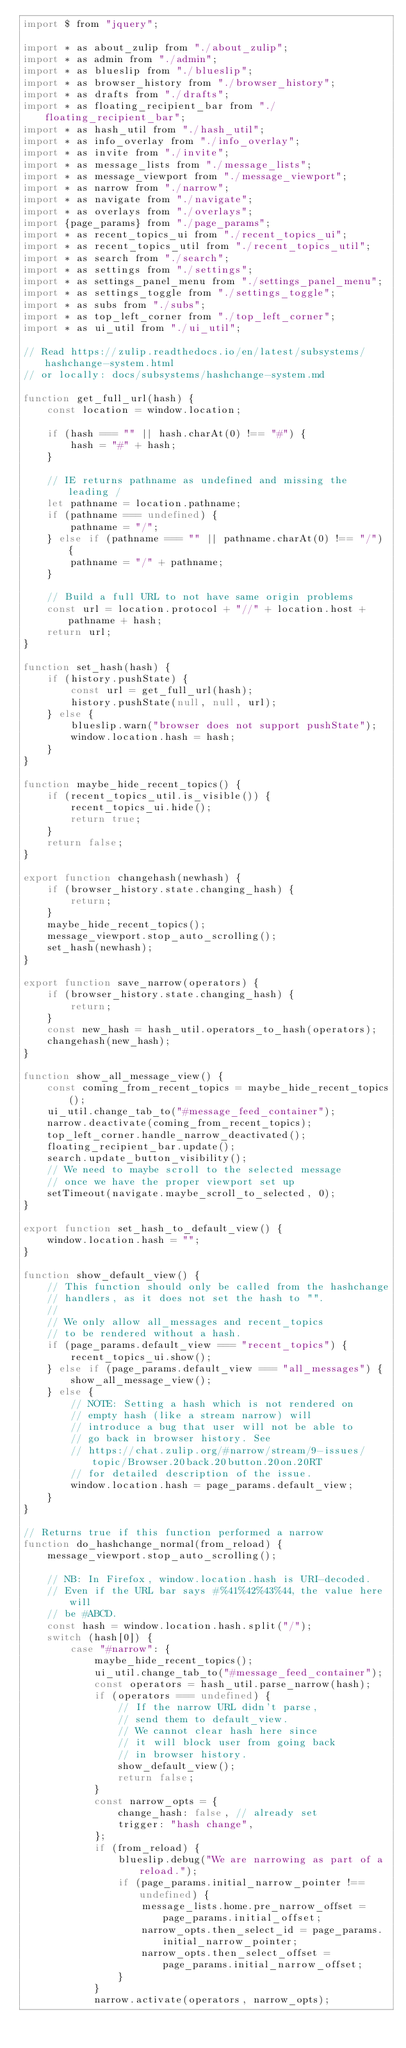Convert code to text. <code><loc_0><loc_0><loc_500><loc_500><_JavaScript_>import $ from "jquery";

import * as about_zulip from "./about_zulip";
import * as admin from "./admin";
import * as blueslip from "./blueslip";
import * as browser_history from "./browser_history";
import * as drafts from "./drafts";
import * as floating_recipient_bar from "./floating_recipient_bar";
import * as hash_util from "./hash_util";
import * as info_overlay from "./info_overlay";
import * as invite from "./invite";
import * as message_lists from "./message_lists";
import * as message_viewport from "./message_viewport";
import * as narrow from "./narrow";
import * as navigate from "./navigate";
import * as overlays from "./overlays";
import {page_params} from "./page_params";
import * as recent_topics_ui from "./recent_topics_ui";
import * as recent_topics_util from "./recent_topics_util";
import * as search from "./search";
import * as settings from "./settings";
import * as settings_panel_menu from "./settings_panel_menu";
import * as settings_toggle from "./settings_toggle";
import * as subs from "./subs";
import * as top_left_corner from "./top_left_corner";
import * as ui_util from "./ui_util";

// Read https://zulip.readthedocs.io/en/latest/subsystems/hashchange-system.html
// or locally: docs/subsystems/hashchange-system.md

function get_full_url(hash) {
    const location = window.location;

    if (hash === "" || hash.charAt(0) !== "#") {
        hash = "#" + hash;
    }

    // IE returns pathname as undefined and missing the leading /
    let pathname = location.pathname;
    if (pathname === undefined) {
        pathname = "/";
    } else if (pathname === "" || pathname.charAt(0) !== "/") {
        pathname = "/" + pathname;
    }

    // Build a full URL to not have same origin problems
    const url = location.protocol + "//" + location.host + pathname + hash;
    return url;
}

function set_hash(hash) {
    if (history.pushState) {
        const url = get_full_url(hash);
        history.pushState(null, null, url);
    } else {
        blueslip.warn("browser does not support pushState");
        window.location.hash = hash;
    }
}

function maybe_hide_recent_topics() {
    if (recent_topics_util.is_visible()) {
        recent_topics_ui.hide();
        return true;
    }
    return false;
}

export function changehash(newhash) {
    if (browser_history.state.changing_hash) {
        return;
    }
    maybe_hide_recent_topics();
    message_viewport.stop_auto_scrolling();
    set_hash(newhash);
}

export function save_narrow(operators) {
    if (browser_history.state.changing_hash) {
        return;
    }
    const new_hash = hash_util.operators_to_hash(operators);
    changehash(new_hash);
}

function show_all_message_view() {
    const coming_from_recent_topics = maybe_hide_recent_topics();
    ui_util.change_tab_to("#message_feed_container");
    narrow.deactivate(coming_from_recent_topics);
    top_left_corner.handle_narrow_deactivated();
    floating_recipient_bar.update();
    search.update_button_visibility();
    // We need to maybe scroll to the selected message
    // once we have the proper viewport set up
    setTimeout(navigate.maybe_scroll_to_selected, 0);
}

export function set_hash_to_default_view() {
    window.location.hash = "";
}

function show_default_view() {
    // This function should only be called from the hashchange
    // handlers, as it does not set the hash to "".
    //
    // We only allow all_messages and recent_topics
    // to be rendered without a hash.
    if (page_params.default_view === "recent_topics") {
        recent_topics_ui.show();
    } else if (page_params.default_view === "all_messages") {
        show_all_message_view();
    } else {
        // NOTE: Setting a hash which is not rendered on
        // empty hash (like a stream narrow) will
        // introduce a bug that user will not be able to
        // go back in browser history. See
        // https://chat.zulip.org/#narrow/stream/9-issues/topic/Browser.20back.20button.20on.20RT
        // for detailed description of the issue.
        window.location.hash = page_params.default_view;
    }
}

// Returns true if this function performed a narrow
function do_hashchange_normal(from_reload) {
    message_viewport.stop_auto_scrolling();

    // NB: In Firefox, window.location.hash is URI-decoded.
    // Even if the URL bar says #%41%42%43%44, the value here will
    // be #ABCD.
    const hash = window.location.hash.split("/");
    switch (hash[0]) {
        case "#narrow": {
            maybe_hide_recent_topics();
            ui_util.change_tab_to("#message_feed_container");
            const operators = hash_util.parse_narrow(hash);
            if (operators === undefined) {
                // If the narrow URL didn't parse,
                // send them to default_view.
                // We cannot clear hash here since
                // it will block user from going back
                // in browser history.
                show_default_view();
                return false;
            }
            const narrow_opts = {
                change_hash: false, // already set
                trigger: "hash change",
            };
            if (from_reload) {
                blueslip.debug("We are narrowing as part of a reload.");
                if (page_params.initial_narrow_pointer !== undefined) {
                    message_lists.home.pre_narrow_offset = page_params.initial_offset;
                    narrow_opts.then_select_id = page_params.initial_narrow_pointer;
                    narrow_opts.then_select_offset = page_params.initial_narrow_offset;
                }
            }
            narrow.activate(operators, narrow_opts);</code> 